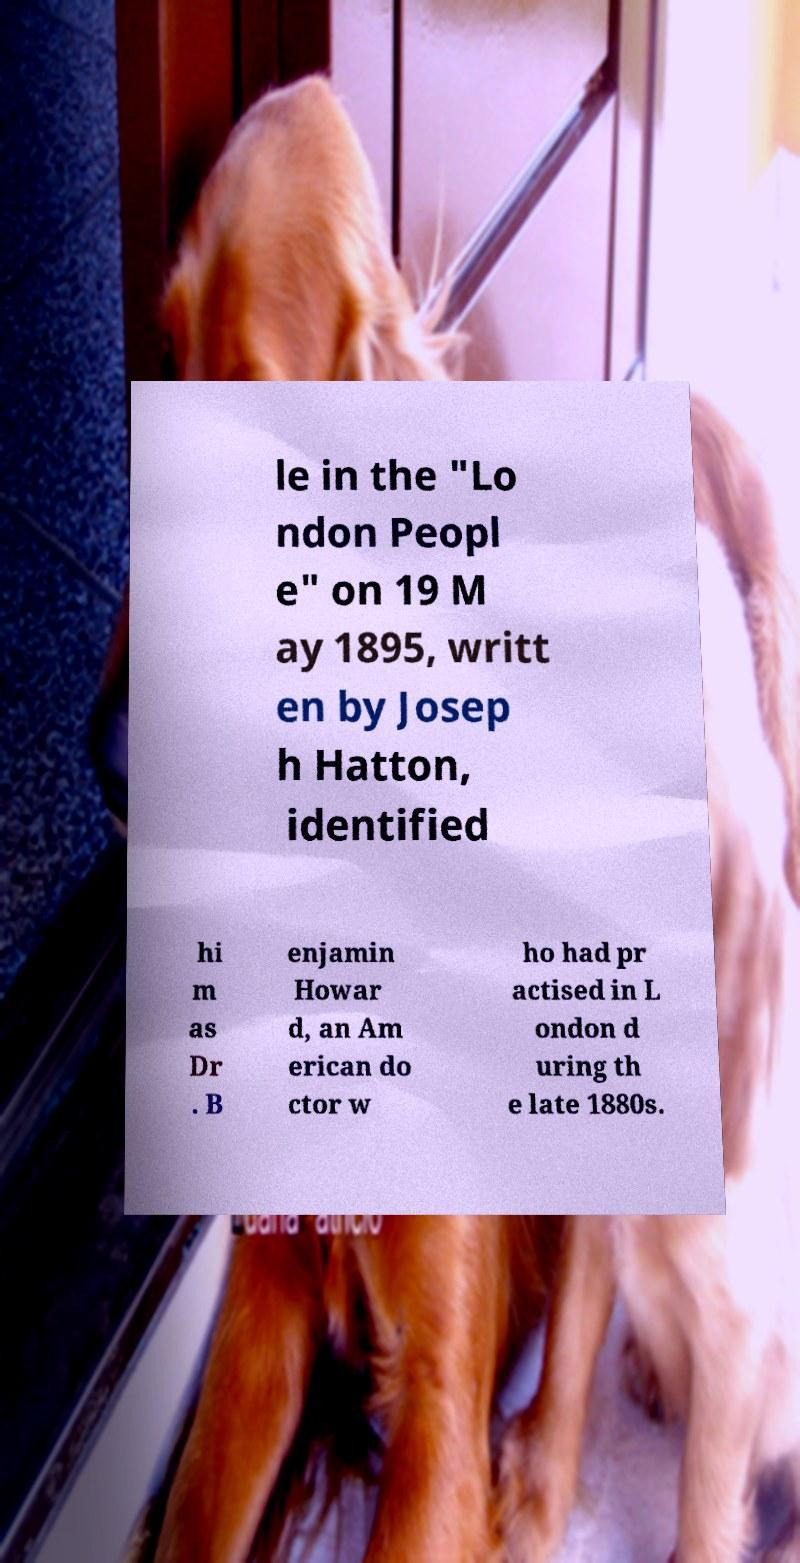Can you read and provide the text displayed in the image?This photo seems to have some interesting text. Can you extract and type it out for me? le in the "Lo ndon Peopl e" on 19 M ay 1895, writt en by Josep h Hatton, identified hi m as Dr . B enjamin Howar d, an Am erican do ctor w ho had pr actised in L ondon d uring th e late 1880s. 